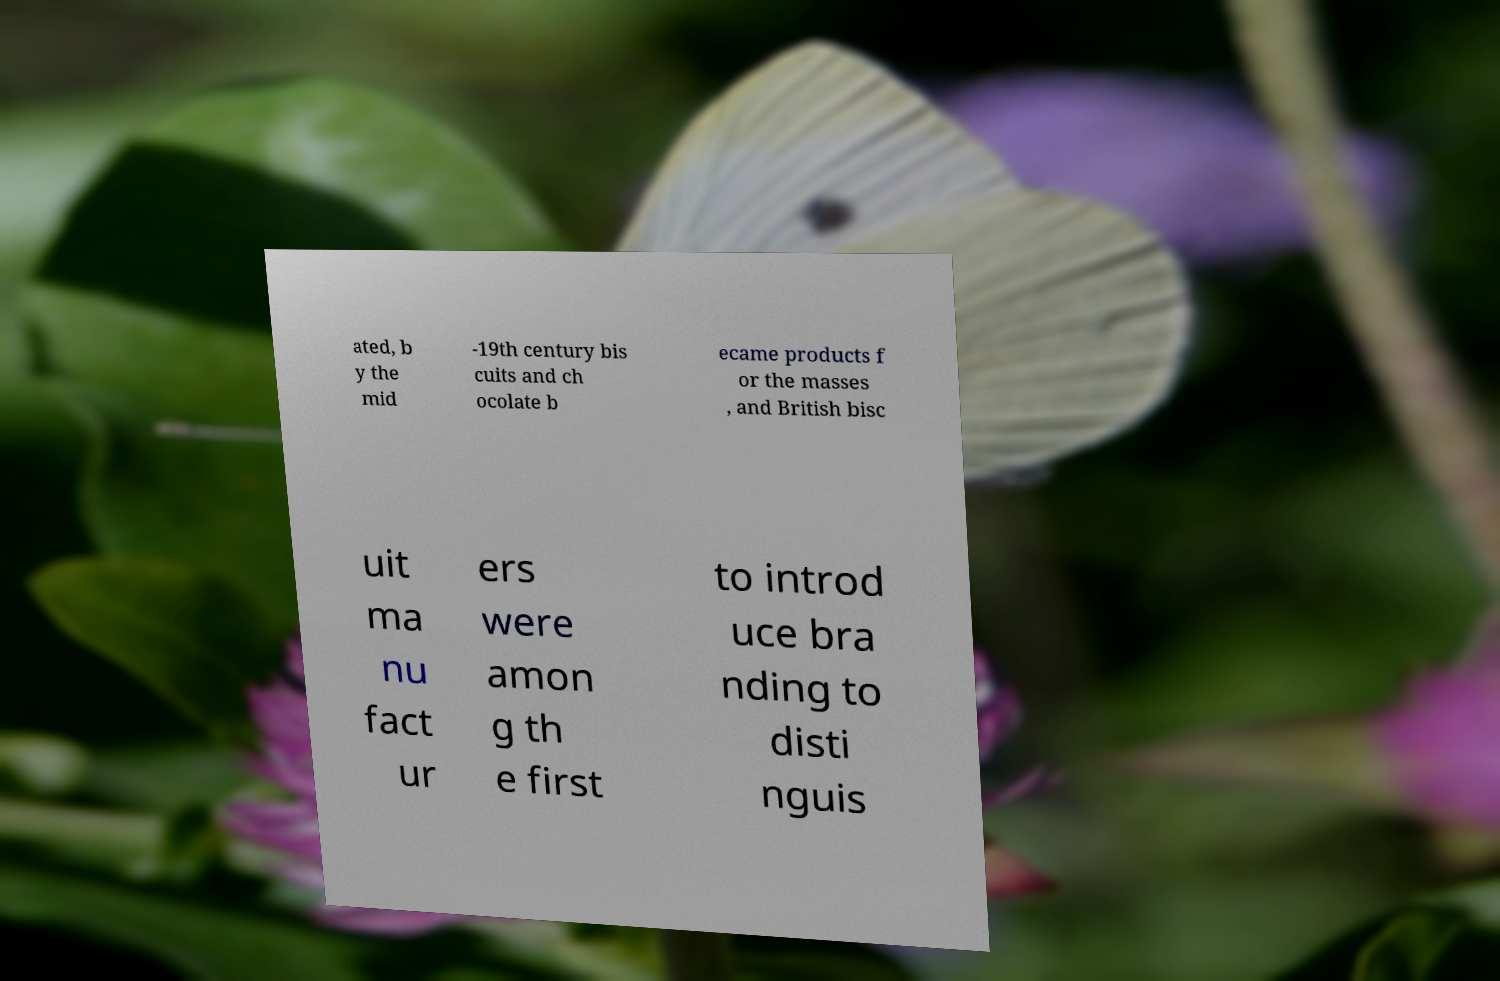I need the written content from this picture converted into text. Can you do that? ated, b y the mid -19th century bis cuits and ch ocolate b ecame products f or the masses , and British bisc uit ma nu fact ur ers were amon g th e first to introd uce bra nding to disti nguis 